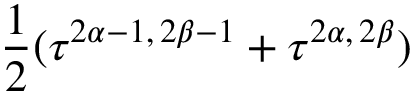Convert formula to latex. <formula><loc_0><loc_0><loc_500><loc_500>\frac { 1 } { 2 } ( \tau ^ { 2 \alpha - 1 , \, 2 \beta - 1 } + \tau ^ { 2 \alpha , \, 2 \beta } )</formula> 